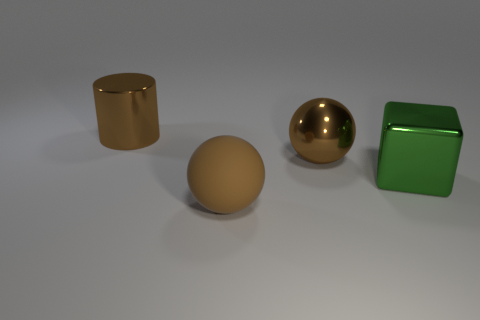Is the material of the brown ball behind the rubber ball the same as the big object in front of the shiny block?
Offer a terse response. No. There is a brown thing that is made of the same material as the large cylinder; what is its size?
Provide a short and direct response. Large. There is a brown shiny thing that is the same shape as the big brown rubber thing; what is its size?
Give a very brief answer. Large. Are there any big cubes?
Ensure brevity in your answer.  Yes. How many objects are either brown things behind the big brown rubber sphere or large green shiny objects?
Ensure brevity in your answer.  3. What material is the brown cylinder that is the same size as the green object?
Ensure brevity in your answer.  Metal. There is a large sphere that is right of the big sphere that is in front of the green metallic block; what is its color?
Give a very brief answer. Brown. How many large brown balls are right of the big metallic cylinder?
Make the answer very short. 2. The large matte object has what color?
Your answer should be compact. Brown. What number of large things are either green objects or brown metallic balls?
Provide a short and direct response. 2. 